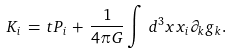<formula> <loc_0><loc_0><loc_500><loc_500>K _ { i } \, = \, t P _ { i } \, + \, \frac { 1 } { 4 \pi G } \int \, d ^ { 3 } x x _ { i } \partial _ { k } g _ { k } .</formula> 